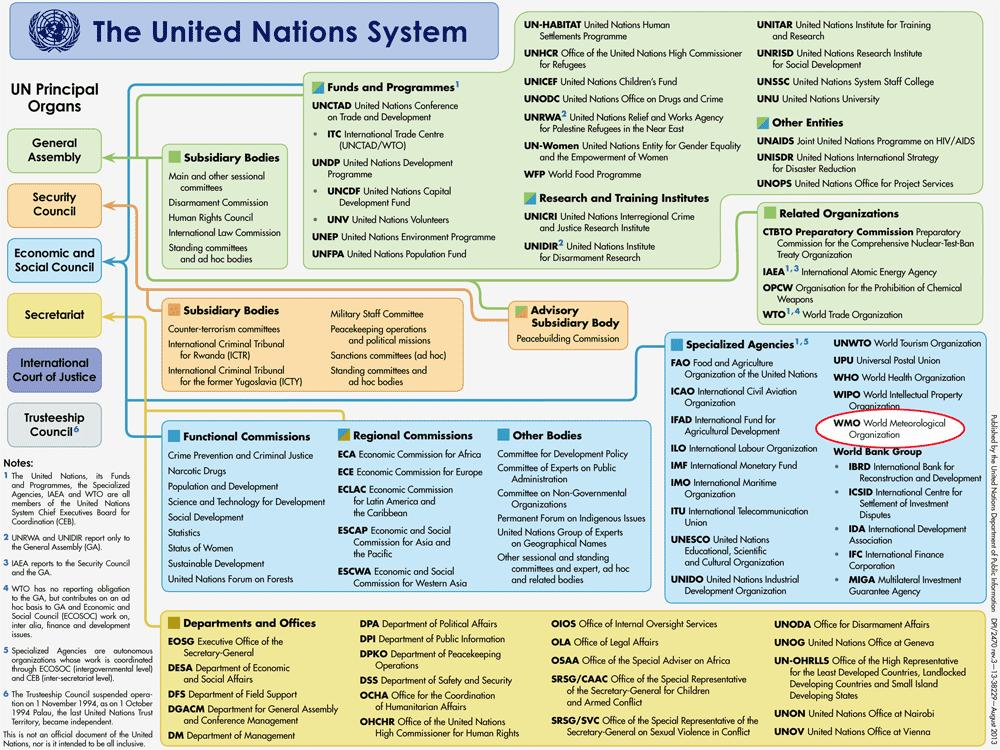Mention a couple of crucial points in this snapshot. There are currently 5 subsidiary bodies associated with the United Nations General Assembly. There are six principal organs of the United Nations. There are seven subsidiary bodies for the United Nations Security Council. The Security Council of the United Nations has two sections. The General Assembly of the United Nations comprises four main sections. 